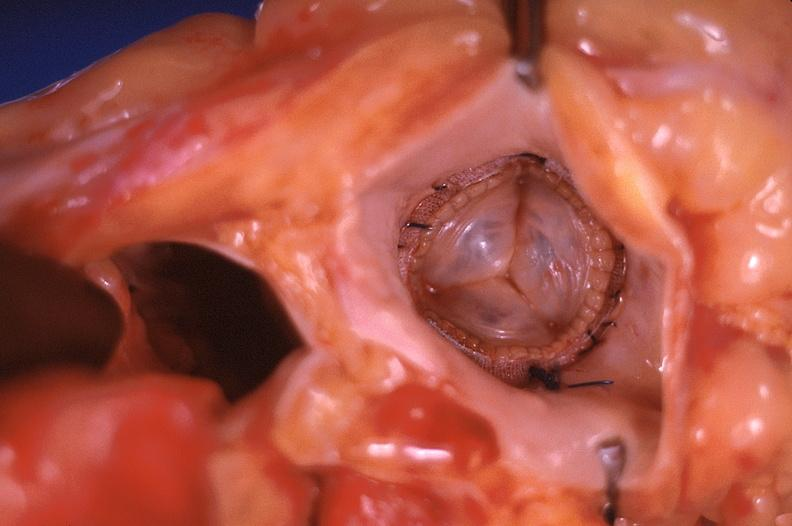does fibrinous peritonitis show prosthetic mitral valve, carpentier-edwards valve bovine pericardial bioprosthesis?
Answer the question using a single word or phrase. No 